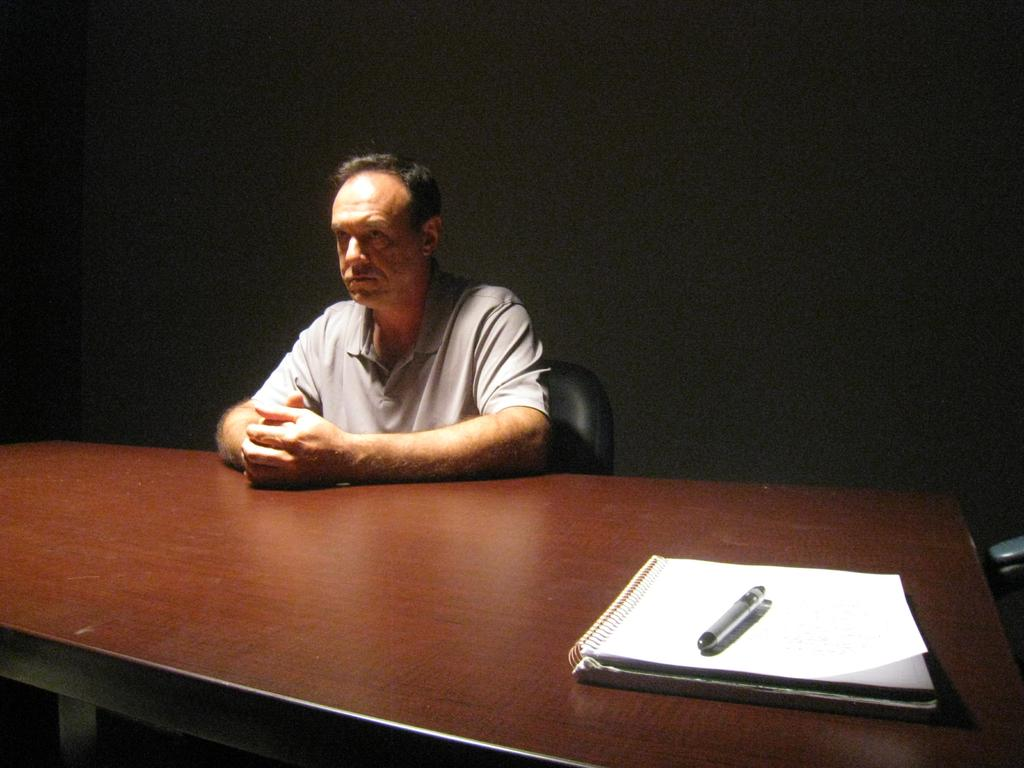What is the person in the image doing? The person is sitting on a chair in the image. Where is the person located in relation to the table? The person is around a table in the image. What items can be seen on the table? There is a book and a pen on the table in the image. What is visible in the background of the image? There is a wall in the background of the image. What is the profit of the book on the table in the image? There is no information about the profit of the book in the image. The image only shows a book and a pen on the table. 